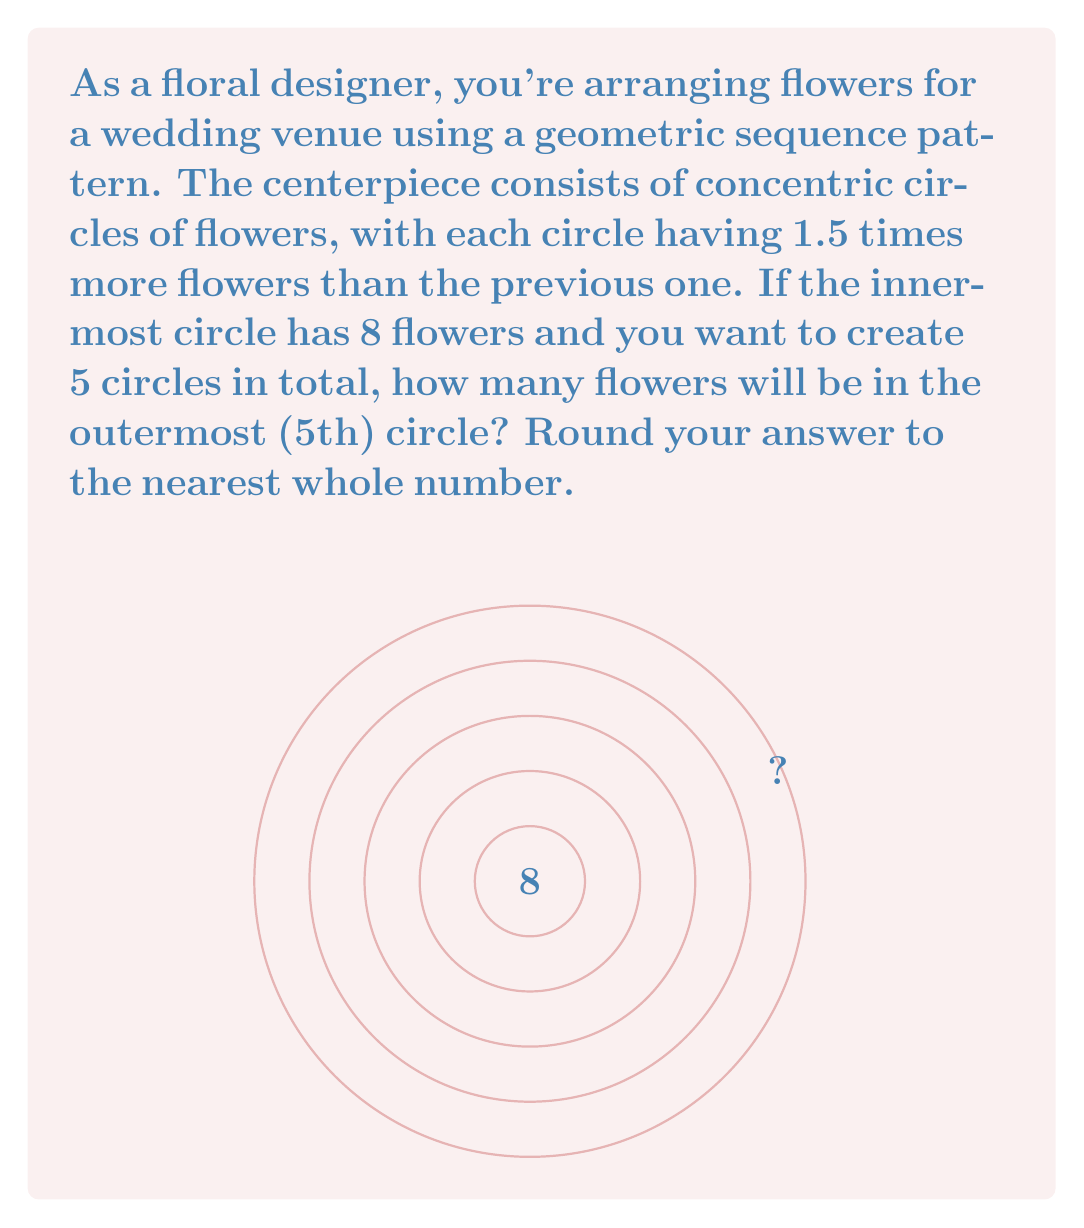Teach me how to tackle this problem. Let's approach this step-by-step using the properties of geometric sequences:

1) We're given that this is a geometric sequence with a common ratio of 1.5.
   The general term of a geometric sequence is given by:
   $$a_n = a_1 \cdot r^{n-1}$$
   where $a_n$ is the nth term, $a_1$ is the first term, and $r$ is the common ratio.

2) In this case:
   $a_1 = 8$ (first circle)
   $r = 1.5$ (each circle has 1.5 times more flowers than the previous one)
   We want to find $a_5$ (5th circle)

3) Plugging these values into our formula:
   $$a_5 = 8 \cdot 1.5^{5-1}$$

4) Simplify the exponent:
   $$a_5 = 8 \cdot 1.5^4$$

5) Calculate:
   $$a_5 = 8 \cdot 5.0625 = 40.5$$

6) Rounding to the nearest whole number:
   $$a_5 \approx 41$$

Therefore, the outermost (5th) circle will have approximately 41 flowers.
Answer: 41 flowers 